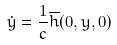<formula> <loc_0><loc_0><loc_500><loc_500>\dot { y } = \frac { 1 } { c } \overline { h } ( 0 , y , 0 )</formula> 